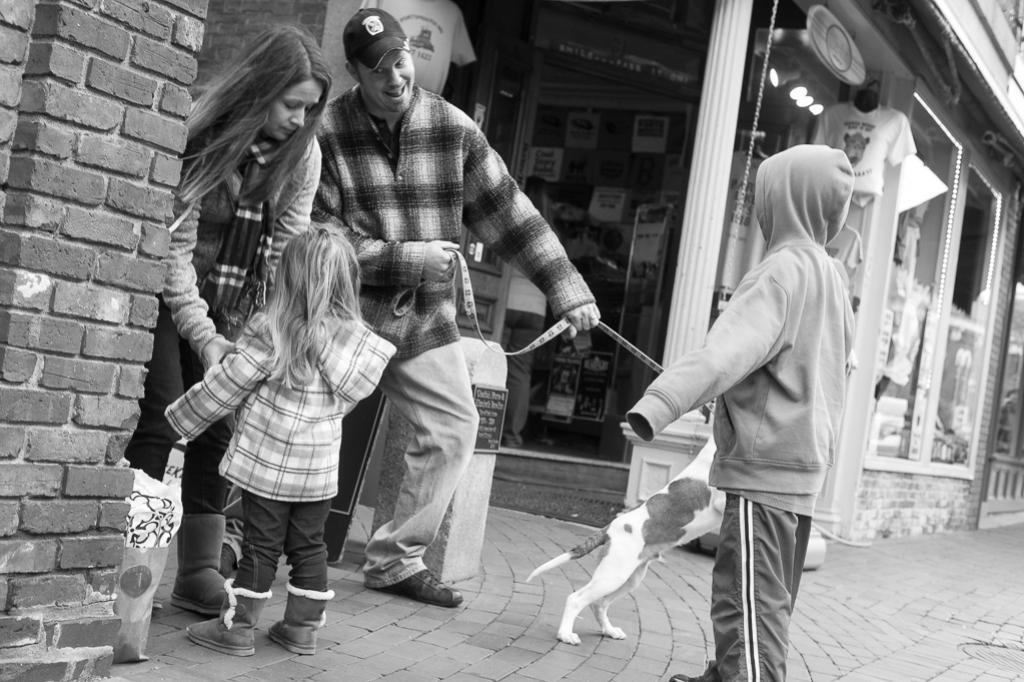Describe this image in one or two sentences. As we can see in the image, there are four people and a cat standing on road. On the left side there is a brick wall and here there is a building. 